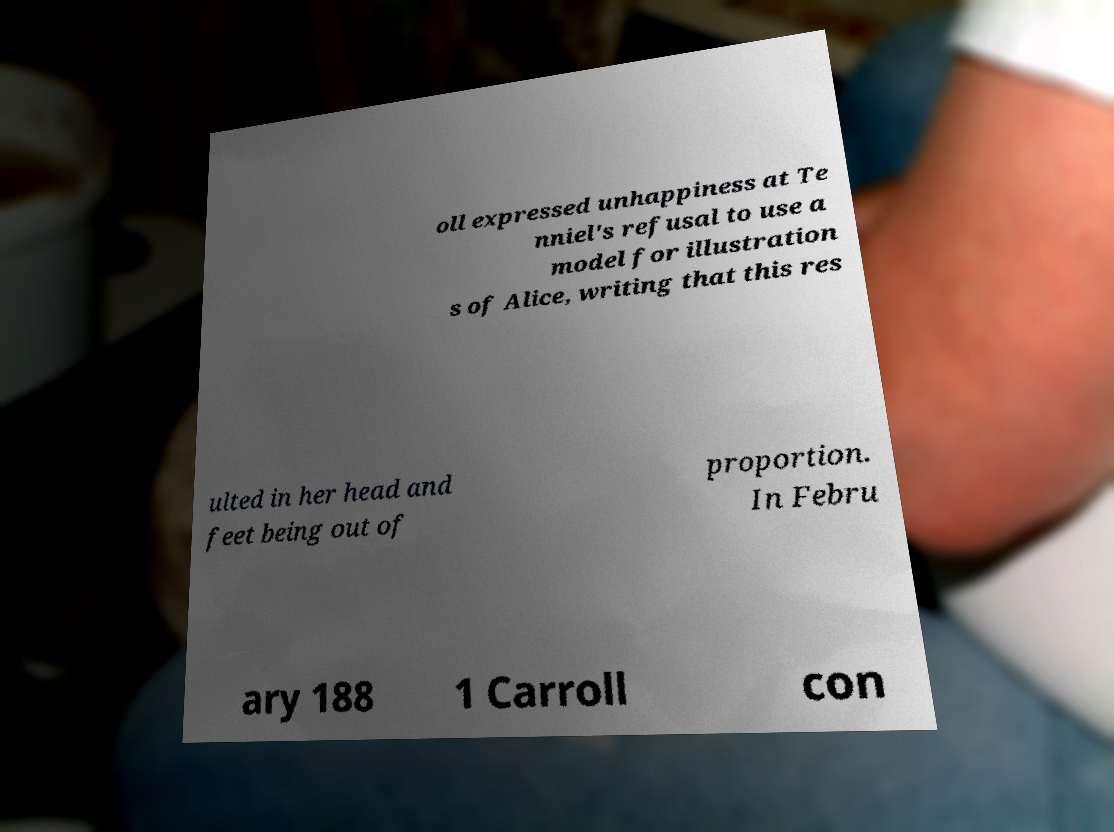Can you read and provide the text displayed in the image?This photo seems to have some interesting text. Can you extract and type it out for me? oll expressed unhappiness at Te nniel's refusal to use a model for illustration s of Alice, writing that this res ulted in her head and feet being out of proportion. In Febru ary 188 1 Carroll con 